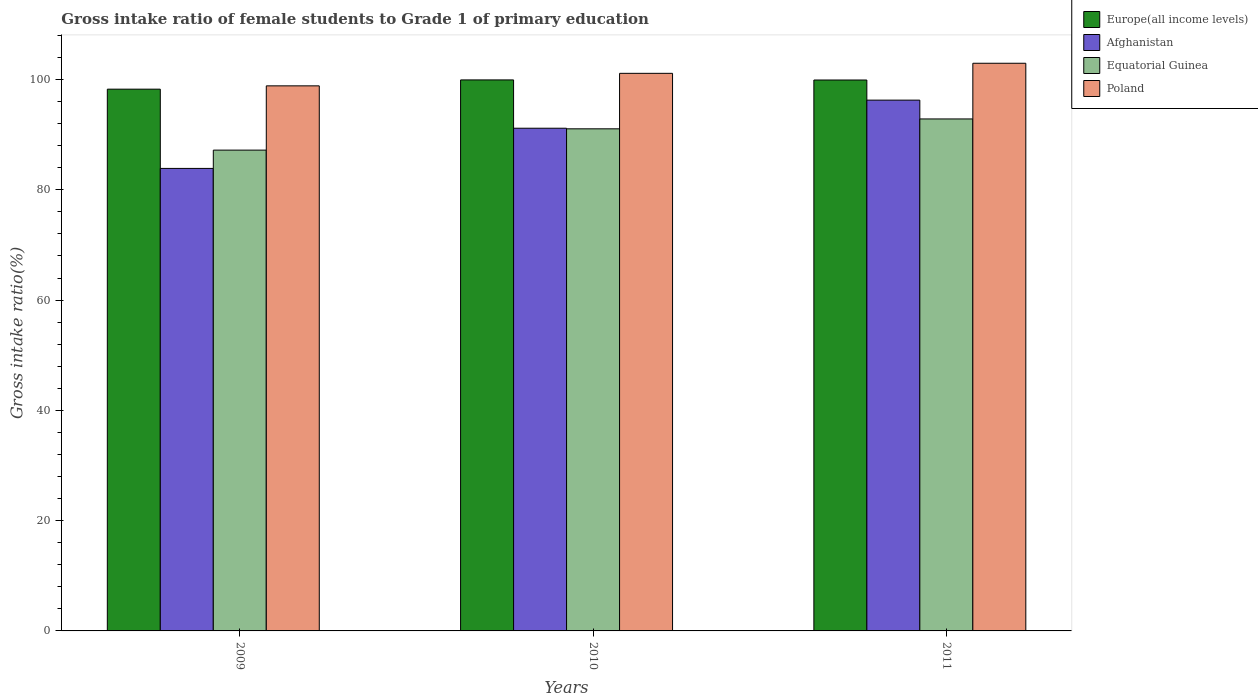How many different coloured bars are there?
Offer a very short reply. 4. How many groups of bars are there?
Offer a very short reply. 3. How many bars are there on the 1st tick from the right?
Ensure brevity in your answer.  4. What is the label of the 2nd group of bars from the left?
Ensure brevity in your answer.  2010. What is the gross intake ratio in Afghanistan in 2011?
Keep it short and to the point. 96.27. Across all years, what is the maximum gross intake ratio in Equatorial Guinea?
Keep it short and to the point. 92.85. Across all years, what is the minimum gross intake ratio in Afghanistan?
Make the answer very short. 83.88. What is the total gross intake ratio in Afghanistan in the graph?
Make the answer very short. 271.32. What is the difference between the gross intake ratio in Europe(all income levels) in 2010 and that in 2011?
Provide a short and direct response. 0.02. What is the difference between the gross intake ratio in Afghanistan in 2011 and the gross intake ratio in Poland in 2009?
Your answer should be very brief. -2.59. What is the average gross intake ratio in Equatorial Guinea per year?
Your answer should be compact. 90.37. In the year 2009, what is the difference between the gross intake ratio in Afghanistan and gross intake ratio in Europe(all income levels)?
Your response must be concise. -14.37. In how many years, is the gross intake ratio in Equatorial Guinea greater than 40 %?
Your answer should be compact. 3. What is the ratio of the gross intake ratio in Equatorial Guinea in 2010 to that in 2011?
Give a very brief answer. 0.98. Is the difference between the gross intake ratio in Afghanistan in 2009 and 2010 greater than the difference between the gross intake ratio in Europe(all income levels) in 2009 and 2010?
Give a very brief answer. No. What is the difference between the highest and the second highest gross intake ratio in Afghanistan?
Your response must be concise. 5.1. What is the difference between the highest and the lowest gross intake ratio in Equatorial Guinea?
Your answer should be very brief. 5.65. In how many years, is the gross intake ratio in Poland greater than the average gross intake ratio in Poland taken over all years?
Keep it short and to the point. 2. Is the sum of the gross intake ratio in Afghanistan in 2009 and 2011 greater than the maximum gross intake ratio in Equatorial Guinea across all years?
Make the answer very short. Yes. Is it the case that in every year, the sum of the gross intake ratio in Poland and gross intake ratio in Europe(all income levels) is greater than the sum of gross intake ratio in Afghanistan and gross intake ratio in Equatorial Guinea?
Give a very brief answer. No. What does the 3rd bar from the right in 2009 represents?
Offer a very short reply. Afghanistan. Is it the case that in every year, the sum of the gross intake ratio in Europe(all income levels) and gross intake ratio in Afghanistan is greater than the gross intake ratio in Equatorial Guinea?
Your response must be concise. Yes. Are all the bars in the graph horizontal?
Provide a succinct answer. No. Does the graph contain any zero values?
Offer a terse response. No. Does the graph contain grids?
Ensure brevity in your answer.  No. How are the legend labels stacked?
Your response must be concise. Vertical. What is the title of the graph?
Make the answer very short. Gross intake ratio of female students to Grade 1 of primary education. Does "St. Lucia" appear as one of the legend labels in the graph?
Offer a very short reply. No. What is the label or title of the Y-axis?
Keep it short and to the point. Gross intake ratio(%). What is the Gross intake ratio(%) in Europe(all income levels) in 2009?
Make the answer very short. 98.25. What is the Gross intake ratio(%) in Afghanistan in 2009?
Provide a succinct answer. 83.88. What is the Gross intake ratio(%) in Equatorial Guinea in 2009?
Provide a succinct answer. 87.2. What is the Gross intake ratio(%) of Poland in 2009?
Keep it short and to the point. 98.85. What is the Gross intake ratio(%) in Europe(all income levels) in 2010?
Offer a very short reply. 99.93. What is the Gross intake ratio(%) in Afghanistan in 2010?
Offer a very short reply. 91.17. What is the Gross intake ratio(%) of Equatorial Guinea in 2010?
Provide a short and direct response. 91.06. What is the Gross intake ratio(%) of Poland in 2010?
Your answer should be compact. 101.13. What is the Gross intake ratio(%) in Europe(all income levels) in 2011?
Your answer should be very brief. 99.91. What is the Gross intake ratio(%) of Afghanistan in 2011?
Make the answer very short. 96.27. What is the Gross intake ratio(%) of Equatorial Guinea in 2011?
Your answer should be compact. 92.85. What is the Gross intake ratio(%) of Poland in 2011?
Provide a succinct answer. 102.95. Across all years, what is the maximum Gross intake ratio(%) in Europe(all income levels)?
Provide a short and direct response. 99.93. Across all years, what is the maximum Gross intake ratio(%) of Afghanistan?
Your response must be concise. 96.27. Across all years, what is the maximum Gross intake ratio(%) of Equatorial Guinea?
Ensure brevity in your answer.  92.85. Across all years, what is the maximum Gross intake ratio(%) of Poland?
Offer a terse response. 102.95. Across all years, what is the minimum Gross intake ratio(%) of Europe(all income levels)?
Provide a short and direct response. 98.25. Across all years, what is the minimum Gross intake ratio(%) of Afghanistan?
Offer a very short reply. 83.88. Across all years, what is the minimum Gross intake ratio(%) in Equatorial Guinea?
Provide a succinct answer. 87.2. Across all years, what is the minimum Gross intake ratio(%) of Poland?
Provide a succinct answer. 98.85. What is the total Gross intake ratio(%) in Europe(all income levels) in the graph?
Provide a succinct answer. 298.1. What is the total Gross intake ratio(%) of Afghanistan in the graph?
Provide a succinct answer. 271.32. What is the total Gross intake ratio(%) in Equatorial Guinea in the graph?
Your response must be concise. 271.12. What is the total Gross intake ratio(%) in Poland in the graph?
Ensure brevity in your answer.  302.93. What is the difference between the Gross intake ratio(%) in Europe(all income levels) in 2009 and that in 2010?
Your answer should be very brief. -1.68. What is the difference between the Gross intake ratio(%) of Afghanistan in 2009 and that in 2010?
Provide a succinct answer. -7.29. What is the difference between the Gross intake ratio(%) in Equatorial Guinea in 2009 and that in 2010?
Offer a terse response. -3.86. What is the difference between the Gross intake ratio(%) in Poland in 2009 and that in 2010?
Your answer should be compact. -2.27. What is the difference between the Gross intake ratio(%) in Europe(all income levels) in 2009 and that in 2011?
Keep it short and to the point. -1.66. What is the difference between the Gross intake ratio(%) in Afghanistan in 2009 and that in 2011?
Your answer should be compact. -12.38. What is the difference between the Gross intake ratio(%) in Equatorial Guinea in 2009 and that in 2011?
Provide a short and direct response. -5.65. What is the difference between the Gross intake ratio(%) in Poland in 2009 and that in 2011?
Your answer should be compact. -4.1. What is the difference between the Gross intake ratio(%) of Europe(all income levels) in 2010 and that in 2011?
Ensure brevity in your answer.  0.02. What is the difference between the Gross intake ratio(%) in Afghanistan in 2010 and that in 2011?
Ensure brevity in your answer.  -5.1. What is the difference between the Gross intake ratio(%) of Equatorial Guinea in 2010 and that in 2011?
Your answer should be compact. -1.79. What is the difference between the Gross intake ratio(%) of Poland in 2010 and that in 2011?
Ensure brevity in your answer.  -1.83. What is the difference between the Gross intake ratio(%) in Europe(all income levels) in 2009 and the Gross intake ratio(%) in Afghanistan in 2010?
Provide a succinct answer. 7.08. What is the difference between the Gross intake ratio(%) of Europe(all income levels) in 2009 and the Gross intake ratio(%) of Equatorial Guinea in 2010?
Ensure brevity in your answer.  7.19. What is the difference between the Gross intake ratio(%) of Europe(all income levels) in 2009 and the Gross intake ratio(%) of Poland in 2010?
Your response must be concise. -2.87. What is the difference between the Gross intake ratio(%) of Afghanistan in 2009 and the Gross intake ratio(%) of Equatorial Guinea in 2010?
Provide a short and direct response. -7.18. What is the difference between the Gross intake ratio(%) of Afghanistan in 2009 and the Gross intake ratio(%) of Poland in 2010?
Your response must be concise. -17.24. What is the difference between the Gross intake ratio(%) of Equatorial Guinea in 2009 and the Gross intake ratio(%) of Poland in 2010?
Offer a terse response. -13.93. What is the difference between the Gross intake ratio(%) of Europe(all income levels) in 2009 and the Gross intake ratio(%) of Afghanistan in 2011?
Offer a very short reply. 1.99. What is the difference between the Gross intake ratio(%) in Europe(all income levels) in 2009 and the Gross intake ratio(%) in Equatorial Guinea in 2011?
Give a very brief answer. 5.4. What is the difference between the Gross intake ratio(%) in Europe(all income levels) in 2009 and the Gross intake ratio(%) in Poland in 2011?
Provide a short and direct response. -4.7. What is the difference between the Gross intake ratio(%) of Afghanistan in 2009 and the Gross intake ratio(%) of Equatorial Guinea in 2011?
Offer a terse response. -8.97. What is the difference between the Gross intake ratio(%) in Afghanistan in 2009 and the Gross intake ratio(%) in Poland in 2011?
Give a very brief answer. -19.07. What is the difference between the Gross intake ratio(%) of Equatorial Guinea in 2009 and the Gross intake ratio(%) of Poland in 2011?
Make the answer very short. -15.75. What is the difference between the Gross intake ratio(%) of Europe(all income levels) in 2010 and the Gross intake ratio(%) of Afghanistan in 2011?
Offer a very short reply. 3.67. What is the difference between the Gross intake ratio(%) of Europe(all income levels) in 2010 and the Gross intake ratio(%) of Equatorial Guinea in 2011?
Make the answer very short. 7.08. What is the difference between the Gross intake ratio(%) in Europe(all income levels) in 2010 and the Gross intake ratio(%) in Poland in 2011?
Make the answer very short. -3.02. What is the difference between the Gross intake ratio(%) in Afghanistan in 2010 and the Gross intake ratio(%) in Equatorial Guinea in 2011?
Provide a succinct answer. -1.68. What is the difference between the Gross intake ratio(%) in Afghanistan in 2010 and the Gross intake ratio(%) in Poland in 2011?
Ensure brevity in your answer.  -11.78. What is the difference between the Gross intake ratio(%) of Equatorial Guinea in 2010 and the Gross intake ratio(%) of Poland in 2011?
Give a very brief answer. -11.89. What is the average Gross intake ratio(%) of Europe(all income levels) per year?
Provide a succinct answer. 99.37. What is the average Gross intake ratio(%) in Afghanistan per year?
Your answer should be very brief. 90.44. What is the average Gross intake ratio(%) of Equatorial Guinea per year?
Ensure brevity in your answer.  90.37. What is the average Gross intake ratio(%) in Poland per year?
Ensure brevity in your answer.  100.98. In the year 2009, what is the difference between the Gross intake ratio(%) in Europe(all income levels) and Gross intake ratio(%) in Afghanistan?
Make the answer very short. 14.37. In the year 2009, what is the difference between the Gross intake ratio(%) in Europe(all income levels) and Gross intake ratio(%) in Equatorial Guinea?
Keep it short and to the point. 11.05. In the year 2009, what is the difference between the Gross intake ratio(%) in Afghanistan and Gross intake ratio(%) in Equatorial Guinea?
Offer a terse response. -3.32. In the year 2009, what is the difference between the Gross intake ratio(%) of Afghanistan and Gross intake ratio(%) of Poland?
Provide a short and direct response. -14.97. In the year 2009, what is the difference between the Gross intake ratio(%) of Equatorial Guinea and Gross intake ratio(%) of Poland?
Your response must be concise. -11.65. In the year 2010, what is the difference between the Gross intake ratio(%) of Europe(all income levels) and Gross intake ratio(%) of Afghanistan?
Make the answer very short. 8.76. In the year 2010, what is the difference between the Gross intake ratio(%) in Europe(all income levels) and Gross intake ratio(%) in Equatorial Guinea?
Offer a terse response. 8.87. In the year 2010, what is the difference between the Gross intake ratio(%) in Europe(all income levels) and Gross intake ratio(%) in Poland?
Offer a very short reply. -1.19. In the year 2010, what is the difference between the Gross intake ratio(%) of Afghanistan and Gross intake ratio(%) of Equatorial Guinea?
Offer a terse response. 0.11. In the year 2010, what is the difference between the Gross intake ratio(%) in Afghanistan and Gross intake ratio(%) in Poland?
Provide a short and direct response. -9.96. In the year 2010, what is the difference between the Gross intake ratio(%) of Equatorial Guinea and Gross intake ratio(%) of Poland?
Ensure brevity in your answer.  -10.06. In the year 2011, what is the difference between the Gross intake ratio(%) in Europe(all income levels) and Gross intake ratio(%) in Afghanistan?
Give a very brief answer. 3.65. In the year 2011, what is the difference between the Gross intake ratio(%) of Europe(all income levels) and Gross intake ratio(%) of Equatorial Guinea?
Give a very brief answer. 7.06. In the year 2011, what is the difference between the Gross intake ratio(%) in Europe(all income levels) and Gross intake ratio(%) in Poland?
Make the answer very short. -3.04. In the year 2011, what is the difference between the Gross intake ratio(%) in Afghanistan and Gross intake ratio(%) in Equatorial Guinea?
Offer a very short reply. 3.41. In the year 2011, what is the difference between the Gross intake ratio(%) in Afghanistan and Gross intake ratio(%) in Poland?
Keep it short and to the point. -6.69. In the year 2011, what is the difference between the Gross intake ratio(%) of Equatorial Guinea and Gross intake ratio(%) of Poland?
Your answer should be compact. -10.1. What is the ratio of the Gross intake ratio(%) in Europe(all income levels) in 2009 to that in 2010?
Your answer should be compact. 0.98. What is the ratio of the Gross intake ratio(%) of Afghanistan in 2009 to that in 2010?
Ensure brevity in your answer.  0.92. What is the ratio of the Gross intake ratio(%) of Equatorial Guinea in 2009 to that in 2010?
Offer a very short reply. 0.96. What is the ratio of the Gross intake ratio(%) of Poland in 2009 to that in 2010?
Your answer should be compact. 0.98. What is the ratio of the Gross intake ratio(%) in Europe(all income levels) in 2009 to that in 2011?
Your answer should be very brief. 0.98. What is the ratio of the Gross intake ratio(%) in Afghanistan in 2009 to that in 2011?
Ensure brevity in your answer.  0.87. What is the ratio of the Gross intake ratio(%) of Equatorial Guinea in 2009 to that in 2011?
Your response must be concise. 0.94. What is the ratio of the Gross intake ratio(%) in Poland in 2009 to that in 2011?
Offer a terse response. 0.96. What is the ratio of the Gross intake ratio(%) of Afghanistan in 2010 to that in 2011?
Your response must be concise. 0.95. What is the ratio of the Gross intake ratio(%) of Equatorial Guinea in 2010 to that in 2011?
Offer a very short reply. 0.98. What is the ratio of the Gross intake ratio(%) in Poland in 2010 to that in 2011?
Provide a short and direct response. 0.98. What is the difference between the highest and the second highest Gross intake ratio(%) of Europe(all income levels)?
Provide a short and direct response. 0.02. What is the difference between the highest and the second highest Gross intake ratio(%) of Afghanistan?
Make the answer very short. 5.1. What is the difference between the highest and the second highest Gross intake ratio(%) of Equatorial Guinea?
Offer a terse response. 1.79. What is the difference between the highest and the second highest Gross intake ratio(%) in Poland?
Ensure brevity in your answer.  1.83. What is the difference between the highest and the lowest Gross intake ratio(%) of Europe(all income levels)?
Make the answer very short. 1.68. What is the difference between the highest and the lowest Gross intake ratio(%) of Afghanistan?
Provide a succinct answer. 12.38. What is the difference between the highest and the lowest Gross intake ratio(%) of Equatorial Guinea?
Your answer should be very brief. 5.65. What is the difference between the highest and the lowest Gross intake ratio(%) in Poland?
Keep it short and to the point. 4.1. 